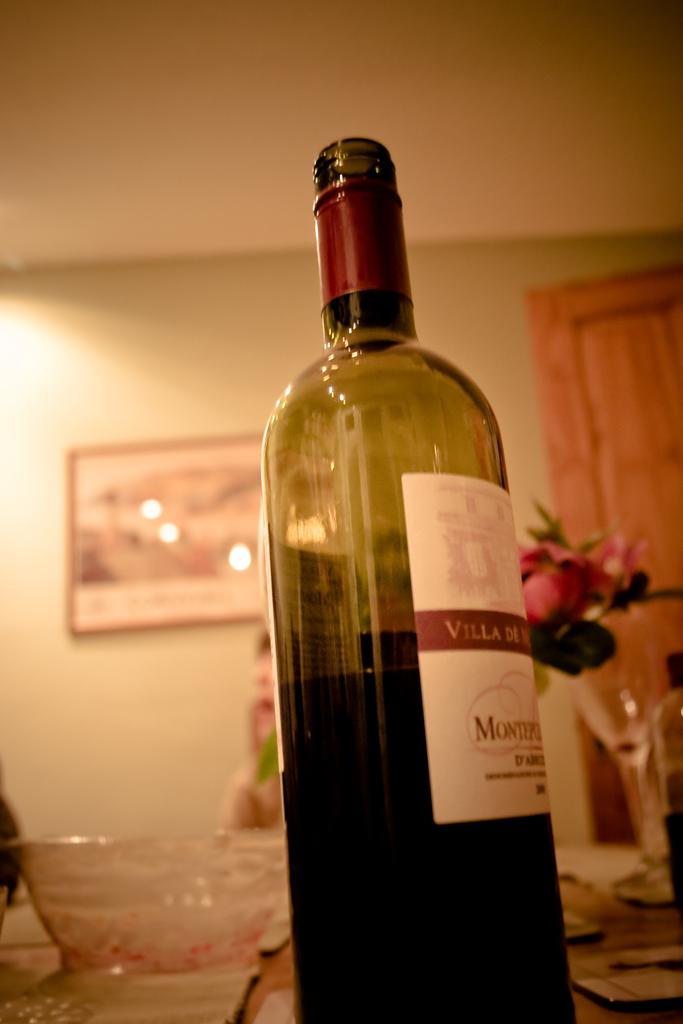What objects can be seen in the image? There is a bottle and a cup in the image. What can be found in the background of the image? There is a flower pot, a person, a frame attached to a wall, and a wooden door in the background of the image. What type of paper is being used to write a letter in the image? There is no paper or writing activity present in the image. 